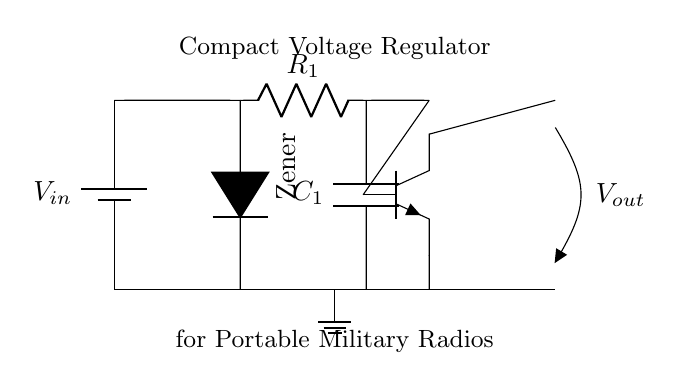What type of diode is used in this circuit? The circuit shows the symbol for a Zener diode, which is characterized by a reverse breakdown voltage that allows it to regulate voltage. This is depicted by the D symbol with an asterisk (*) indicating it's a Zener type.
Answer: Zener diode What is the function of the resistor labeled R1? Resistor R1 is used to limit the current flowing into the Zener diode. This is important because it prevents excessive current that could damage the diode. A lower resistance would increase current flow, potentially leading to failure.
Answer: Current limiting What is the output voltage label in this circuit? The output voltage is labeled as V-out, indicating the voltage that can be used by the connected load. This label is present alongside the output connection from the collector of the transistor.
Answer: V-out How many capacitors are in the circuit? There is one capacitor in the circuit, labeled C1, which is intended to smooth out voltage fluctuations and stabilize the output. Capacitors often help in filtering noise and enhancing performance in power circuits.
Answer: One What type of transistor is depicted in the circuit? The circuit shows an NPN transistor symbol, identified by the configuration of the letters N, P, and the emitter and collector connections. This specifies the direction of current flow and type of transistor used in the regulation process.
Answer: NPN transistor What is the purpose of the capacitor labeled C1? The capacitor C1 is used to filter and smooth the output voltage by reducing ripple voltage, which enhances the stability of the power supply for the portable military radios. It stores charge and releases it to maintain a steady output.
Answer: Smoothing output What is the main application of this voltage regulator circuit? This circuit is specifically designed for portable military radios, providing a stable voltage supply that is crucial for reliable communication equipment in the field. Its compact design optimizes space and performance for tactical gear.
Answer: Portable military radios 